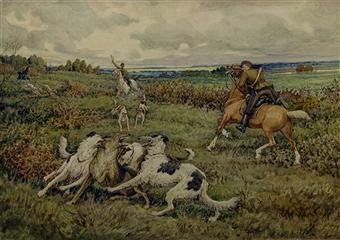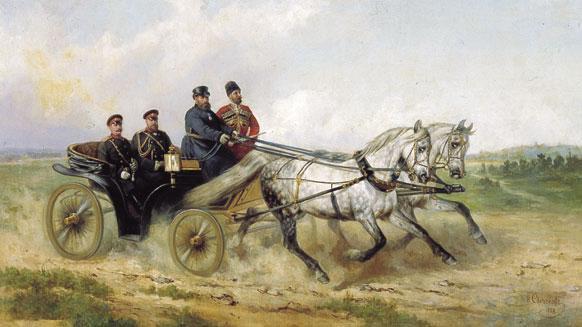The first image is the image on the left, the second image is the image on the right. Assess this claim about the two images: "One image shows at least one man on a horse with at least two dogs standing next to the horse, and the other image shows horses but no wagon.". Correct or not? Answer yes or no. No. 